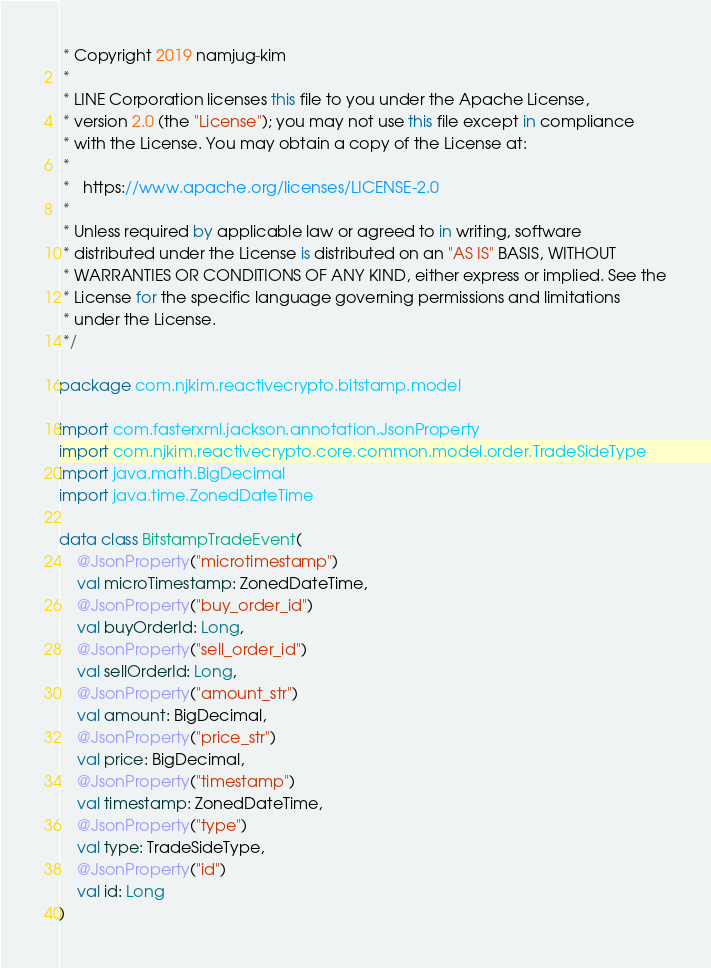<code> <loc_0><loc_0><loc_500><loc_500><_Kotlin_> * Copyright 2019 namjug-kim
 *
 * LINE Corporation licenses this file to you under the Apache License,
 * version 2.0 (the "License"); you may not use this file except in compliance
 * with the License. You may obtain a copy of the License at:
 *
 *   https://www.apache.org/licenses/LICENSE-2.0
 *
 * Unless required by applicable law or agreed to in writing, software
 * distributed under the License is distributed on an "AS IS" BASIS, WITHOUT
 * WARRANTIES OR CONDITIONS OF ANY KIND, either express or implied. See the
 * License for the specific language governing permissions and limitations
 * under the License.
 */

package com.njkim.reactivecrypto.bitstamp.model

import com.fasterxml.jackson.annotation.JsonProperty
import com.njkim.reactivecrypto.core.common.model.order.TradeSideType
import java.math.BigDecimal
import java.time.ZonedDateTime

data class BitstampTradeEvent(
    @JsonProperty("microtimestamp")
    val microTimestamp: ZonedDateTime,
    @JsonProperty("buy_order_id")
    val buyOrderId: Long,
    @JsonProperty("sell_order_id")
    val sellOrderId: Long,
    @JsonProperty("amount_str")
    val amount: BigDecimal,
    @JsonProperty("price_str")
    val price: BigDecimal,
    @JsonProperty("timestamp")
    val timestamp: ZonedDateTime,
    @JsonProperty("type")
    val type: TradeSideType,
    @JsonProperty("id")
    val id: Long
)
</code> 